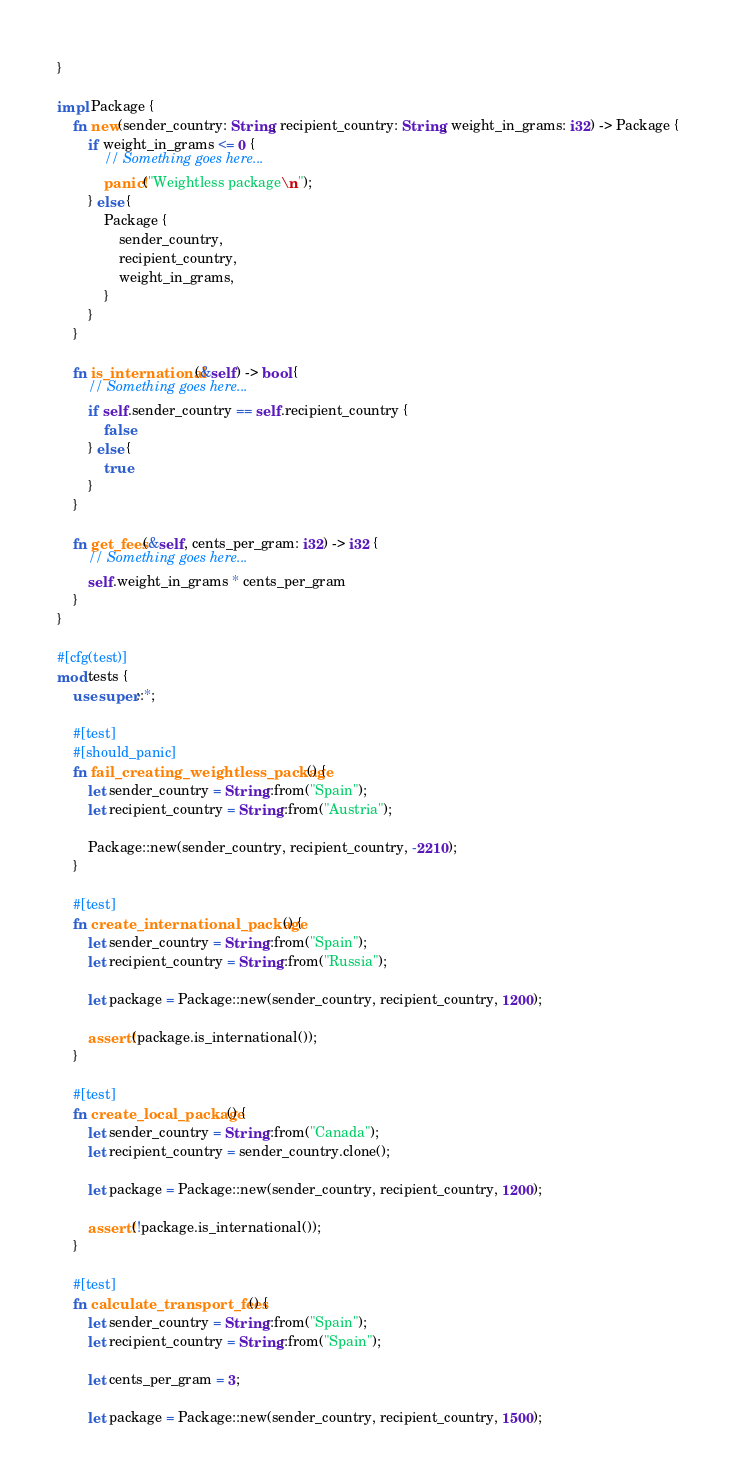Convert code to text. <code><loc_0><loc_0><loc_500><loc_500><_Rust_>}

impl Package {
    fn new(sender_country: String, recipient_country: String, weight_in_grams: i32) -> Package {
        if weight_in_grams <= 0 {
            // Something goes here...
            panic!("Weightless package\n");
        } else {
            Package {
                sender_country,
                recipient_country,
                weight_in_grams,
            }
        }
    }

    fn is_international(&self) -> bool {
        // Something goes here...
        if self.sender_country == self.recipient_country {
            false
        } else {
            true
        }
    }

    fn get_fees(&self, cents_per_gram: i32) -> i32 {
        // Something goes here...
        self.weight_in_grams * cents_per_gram
    }
}

#[cfg(test)]
mod tests {
    use super::*;

    #[test]
    #[should_panic]
    fn fail_creating_weightless_package() {
        let sender_country = String::from("Spain");
        let recipient_country = String::from("Austria");

        Package::new(sender_country, recipient_country, -2210);
    }

    #[test]
    fn create_international_package() {
        let sender_country = String::from("Spain");
        let recipient_country = String::from("Russia");

        let package = Package::new(sender_country, recipient_country, 1200);

        assert!(package.is_international());
    }

    #[test]
    fn create_local_package() {
        let sender_country = String::from("Canada");
        let recipient_country = sender_country.clone();

        let package = Package::new(sender_country, recipient_country, 1200);

        assert!(!package.is_international());
    }

    #[test]
    fn calculate_transport_fees() {
        let sender_country = String::from("Spain");
        let recipient_country = String::from("Spain");

        let cents_per_gram = 3;

        let package = Package::new(sender_country, recipient_country, 1500);
</code> 